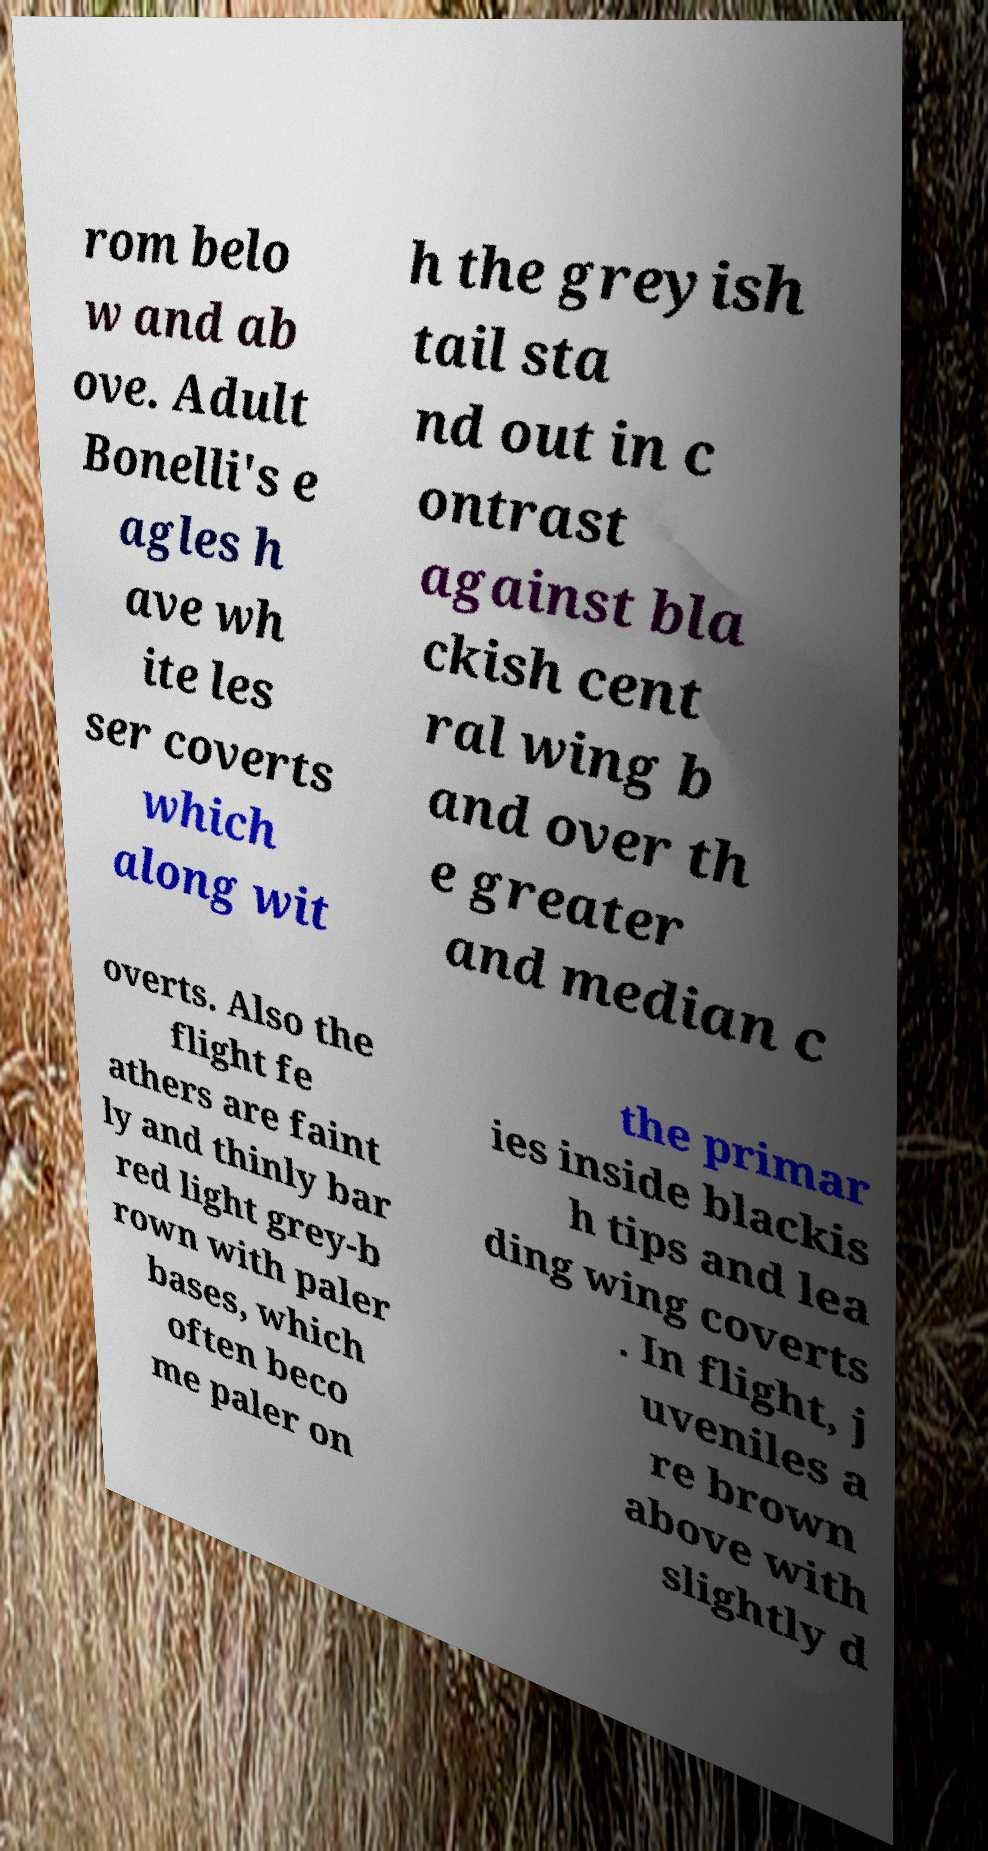For documentation purposes, I need the text within this image transcribed. Could you provide that? rom belo w and ab ove. Adult Bonelli's e agles h ave wh ite les ser coverts which along wit h the greyish tail sta nd out in c ontrast against bla ckish cent ral wing b and over th e greater and median c overts. Also the flight fe athers are faint ly and thinly bar red light grey-b rown with paler bases, which often beco me paler on the primar ies inside blackis h tips and lea ding wing coverts . In flight, j uveniles a re brown above with slightly d 